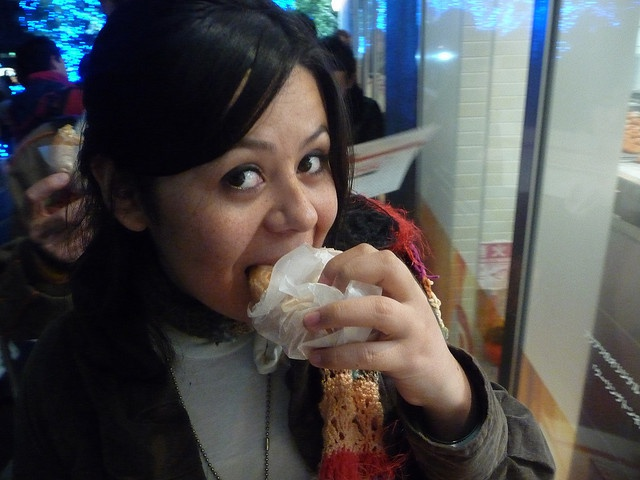Describe the objects in this image and their specific colors. I can see people in black, gray, and maroon tones, people in black, navy, and purple tones, people in black and gray tones, donut in black, gray, and darkgray tones, and donut in black, gray, and maroon tones in this image. 